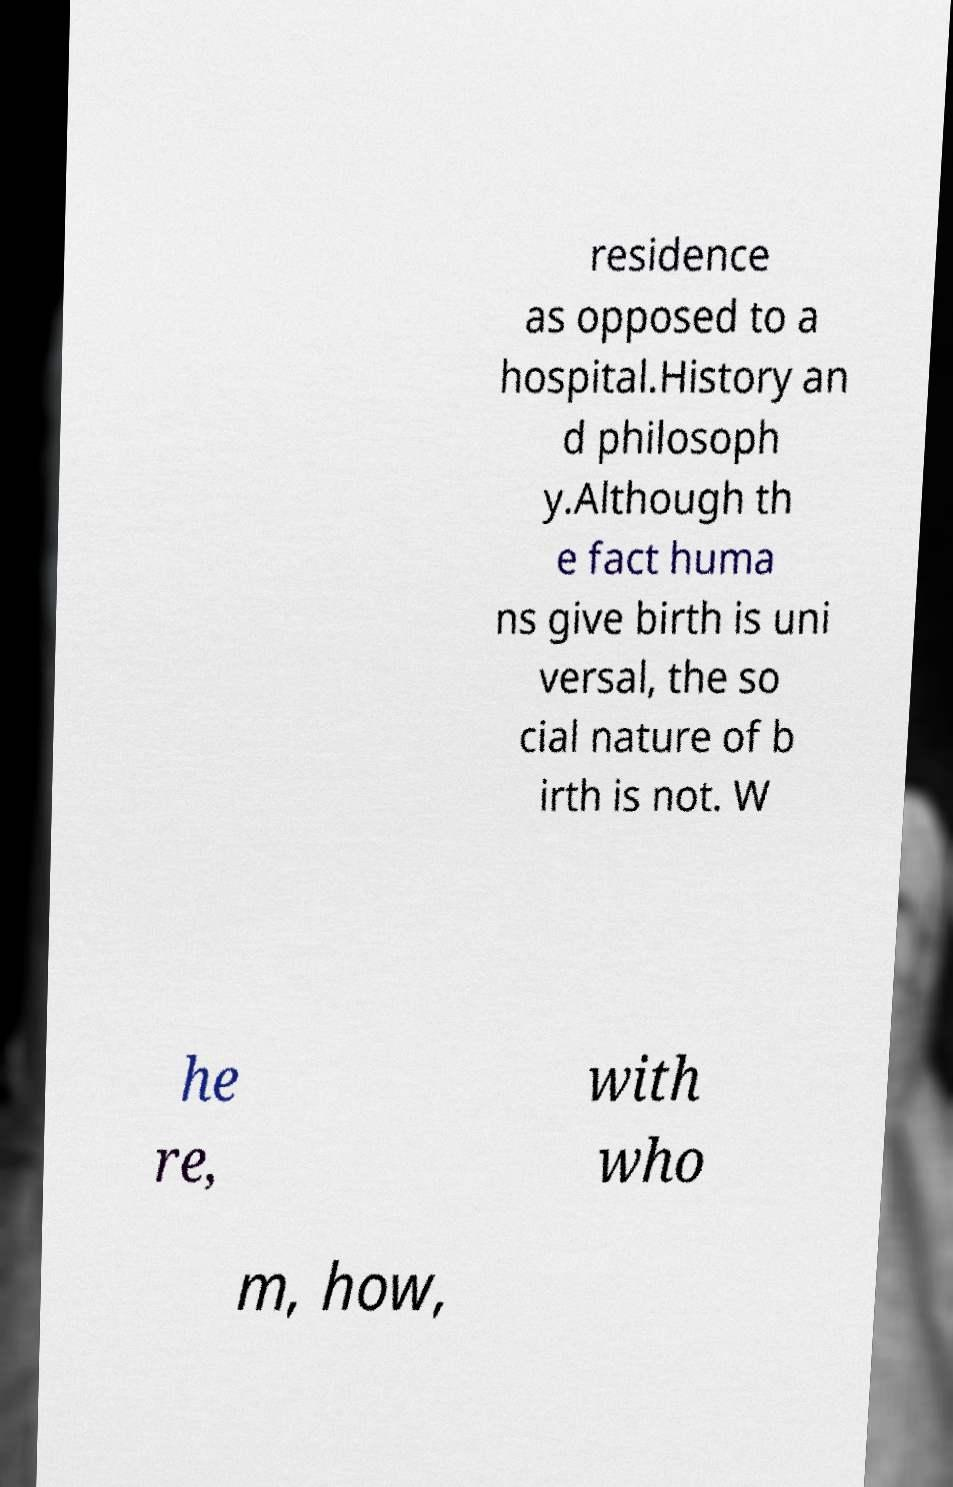I need the written content from this picture converted into text. Can you do that? residence as opposed to a hospital.History an d philosoph y.Although th e fact huma ns give birth is uni versal, the so cial nature of b irth is not. W he re, with who m, how, 